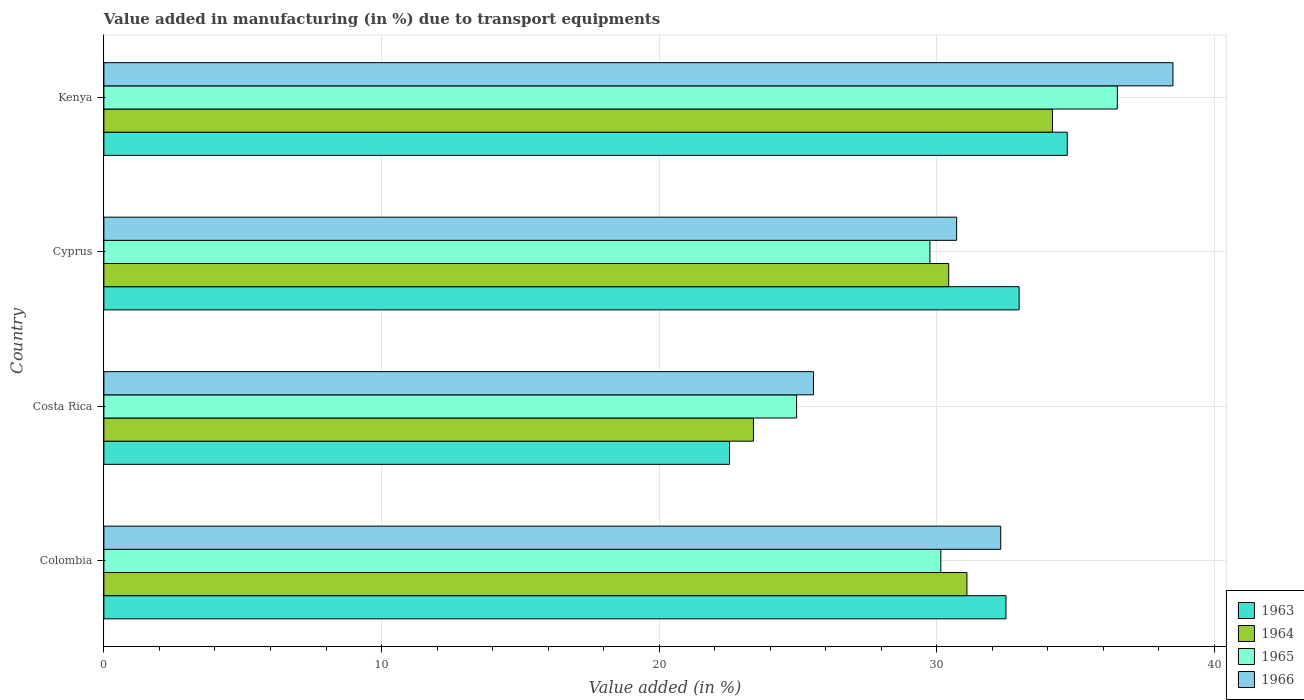Are the number of bars per tick equal to the number of legend labels?
Provide a succinct answer. Yes. How many bars are there on the 1st tick from the top?
Keep it short and to the point. 4. What is the label of the 4th group of bars from the top?
Ensure brevity in your answer.  Colombia. In how many cases, is the number of bars for a given country not equal to the number of legend labels?
Provide a short and direct response. 0. What is the percentage of value added in manufacturing due to transport equipments in 1964 in Costa Rica?
Give a very brief answer. 23.4. Across all countries, what is the maximum percentage of value added in manufacturing due to transport equipments in 1963?
Provide a short and direct response. 34.7. Across all countries, what is the minimum percentage of value added in manufacturing due to transport equipments in 1966?
Provide a succinct answer. 25.56. In which country was the percentage of value added in manufacturing due to transport equipments in 1964 maximum?
Keep it short and to the point. Kenya. In which country was the percentage of value added in manufacturing due to transport equipments in 1966 minimum?
Your answer should be compact. Costa Rica. What is the total percentage of value added in manufacturing due to transport equipments in 1965 in the graph?
Your answer should be compact. 121.35. What is the difference between the percentage of value added in manufacturing due to transport equipments in 1966 in Cyprus and that in Kenya?
Provide a succinct answer. -7.79. What is the difference between the percentage of value added in manufacturing due to transport equipments in 1963 in Colombia and the percentage of value added in manufacturing due to transport equipments in 1966 in Costa Rica?
Provide a succinct answer. 6.93. What is the average percentage of value added in manufacturing due to transport equipments in 1966 per country?
Your answer should be compact. 31.77. What is the difference between the percentage of value added in manufacturing due to transport equipments in 1963 and percentage of value added in manufacturing due to transport equipments in 1965 in Cyprus?
Make the answer very short. 3.21. In how many countries, is the percentage of value added in manufacturing due to transport equipments in 1966 greater than 10 %?
Your answer should be compact. 4. What is the ratio of the percentage of value added in manufacturing due to transport equipments in 1966 in Costa Rica to that in Kenya?
Your response must be concise. 0.66. What is the difference between the highest and the second highest percentage of value added in manufacturing due to transport equipments in 1966?
Your response must be concise. 6.2. What is the difference between the highest and the lowest percentage of value added in manufacturing due to transport equipments in 1965?
Ensure brevity in your answer.  11.55. What does the 2nd bar from the top in Colombia represents?
Keep it short and to the point. 1965. What does the 2nd bar from the bottom in Cyprus represents?
Provide a succinct answer. 1964. Is it the case that in every country, the sum of the percentage of value added in manufacturing due to transport equipments in 1966 and percentage of value added in manufacturing due to transport equipments in 1964 is greater than the percentage of value added in manufacturing due to transport equipments in 1965?
Ensure brevity in your answer.  Yes. Are all the bars in the graph horizontal?
Your answer should be compact. Yes. What is the difference between two consecutive major ticks on the X-axis?
Ensure brevity in your answer.  10. Are the values on the major ticks of X-axis written in scientific E-notation?
Offer a terse response. No. Does the graph contain any zero values?
Make the answer very short. No. Where does the legend appear in the graph?
Offer a terse response. Bottom right. How many legend labels are there?
Provide a short and direct response. 4. What is the title of the graph?
Make the answer very short. Value added in manufacturing (in %) due to transport equipments. What is the label or title of the X-axis?
Make the answer very short. Value added (in %). What is the Value added (in %) in 1963 in Colombia?
Ensure brevity in your answer.  32.49. What is the Value added (in %) of 1964 in Colombia?
Make the answer very short. 31.09. What is the Value added (in %) of 1965 in Colombia?
Keep it short and to the point. 30.15. What is the Value added (in %) in 1966 in Colombia?
Your answer should be compact. 32.3. What is the Value added (in %) in 1963 in Costa Rica?
Your response must be concise. 22.53. What is the Value added (in %) of 1964 in Costa Rica?
Ensure brevity in your answer.  23.4. What is the Value added (in %) of 1965 in Costa Rica?
Ensure brevity in your answer.  24.95. What is the Value added (in %) of 1966 in Costa Rica?
Ensure brevity in your answer.  25.56. What is the Value added (in %) in 1963 in Cyprus?
Provide a succinct answer. 32.97. What is the Value added (in %) in 1964 in Cyprus?
Provide a short and direct response. 30.43. What is the Value added (in %) of 1965 in Cyprus?
Your answer should be very brief. 29.75. What is the Value added (in %) in 1966 in Cyprus?
Your answer should be very brief. 30.72. What is the Value added (in %) of 1963 in Kenya?
Provide a short and direct response. 34.7. What is the Value added (in %) in 1964 in Kenya?
Offer a terse response. 34.17. What is the Value added (in %) in 1965 in Kenya?
Offer a terse response. 36.5. What is the Value added (in %) of 1966 in Kenya?
Your response must be concise. 38.51. Across all countries, what is the maximum Value added (in %) of 1963?
Ensure brevity in your answer.  34.7. Across all countries, what is the maximum Value added (in %) of 1964?
Your answer should be compact. 34.17. Across all countries, what is the maximum Value added (in %) in 1965?
Provide a succinct answer. 36.5. Across all countries, what is the maximum Value added (in %) of 1966?
Keep it short and to the point. 38.51. Across all countries, what is the minimum Value added (in %) of 1963?
Keep it short and to the point. 22.53. Across all countries, what is the minimum Value added (in %) of 1964?
Ensure brevity in your answer.  23.4. Across all countries, what is the minimum Value added (in %) of 1965?
Provide a succinct answer. 24.95. Across all countries, what is the minimum Value added (in %) of 1966?
Provide a short and direct response. 25.56. What is the total Value added (in %) in 1963 in the graph?
Your answer should be very brief. 122.69. What is the total Value added (in %) in 1964 in the graph?
Your answer should be very brief. 119.08. What is the total Value added (in %) of 1965 in the graph?
Your answer should be very brief. 121.35. What is the total Value added (in %) in 1966 in the graph?
Ensure brevity in your answer.  127.09. What is the difference between the Value added (in %) in 1963 in Colombia and that in Costa Rica?
Offer a terse response. 9.96. What is the difference between the Value added (in %) in 1964 in Colombia and that in Costa Rica?
Provide a short and direct response. 7.69. What is the difference between the Value added (in %) in 1965 in Colombia and that in Costa Rica?
Provide a short and direct response. 5.2. What is the difference between the Value added (in %) in 1966 in Colombia and that in Costa Rica?
Your answer should be very brief. 6.74. What is the difference between the Value added (in %) in 1963 in Colombia and that in Cyprus?
Your answer should be compact. -0.47. What is the difference between the Value added (in %) of 1964 in Colombia and that in Cyprus?
Keep it short and to the point. 0.66. What is the difference between the Value added (in %) in 1965 in Colombia and that in Cyprus?
Your response must be concise. 0.39. What is the difference between the Value added (in %) in 1966 in Colombia and that in Cyprus?
Provide a succinct answer. 1.59. What is the difference between the Value added (in %) of 1963 in Colombia and that in Kenya?
Your answer should be very brief. -2.21. What is the difference between the Value added (in %) of 1964 in Colombia and that in Kenya?
Offer a terse response. -3.08. What is the difference between the Value added (in %) in 1965 in Colombia and that in Kenya?
Your answer should be very brief. -6.36. What is the difference between the Value added (in %) of 1966 in Colombia and that in Kenya?
Keep it short and to the point. -6.2. What is the difference between the Value added (in %) in 1963 in Costa Rica and that in Cyprus?
Offer a very short reply. -10.43. What is the difference between the Value added (in %) of 1964 in Costa Rica and that in Cyprus?
Make the answer very short. -7.03. What is the difference between the Value added (in %) in 1965 in Costa Rica and that in Cyprus?
Provide a short and direct response. -4.8. What is the difference between the Value added (in %) in 1966 in Costa Rica and that in Cyprus?
Offer a very short reply. -5.16. What is the difference between the Value added (in %) of 1963 in Costa Rica and that in Kenya?
Your response must be concise. -12.17. What is the difference between the Value added (in %) in 1964 in Costa Rica and that in Kenya?
Ensure brevity in your answer.  -10.77. What is the difference between the Value added (in %) of 1965 in Costa Rica and that in Kenya?
Keep it short and to the point. -11.55. What is the difference between the Value added (in %) of 1966 in Costa Rica and that in Kenya?
Your answer should be very brief. -12.95. What is the difference between the Value added (in %) of 1963 in Cyprus and that in Kenya?
Offer a terse response. -1.73. What is the difference between the Value added (in %) of 1964 in Cyprus and that in Kenya?
Provide a short and direct response. -3.74. What is the difference between the Value added (in %) of 1965 in Cyprus and that in Kenya?
Provide a short and direct response. -6.75. What is the difference between the Value added (in %) in 1966 in Cyprus and that in Kenya?
Your answer should be compact. -7.79. What is the difference between the Value added (in %) in 1963 in Colombia and the Value added (in %) in 1964 in Costa Rica?
Provide a succinct answer. 9.1. What is the difference between the Value added (in %) in 1963 in Colombia and the Value added (in %) in 1965 in Costa Rica?
Keep it short and to the point. 7.54. What is the difference between the Value added (in %) in 1963 in Colombia and the Value added (in %) in 1966 in Costa Rica?
Make the answer very short. 6.93. What is the difference between the Value added (in %) of 1964 in Colombia and the Value added (in %) of 1965 in Costa Rica?
Your response must be concise. 6.14. What is the difference between the Value added (in %) of 1964 in Colombia and the Value added (in %) of 1966 in Costa Rica?
Make the answer very short. 5.53. What is the difference between the Value added (in %) of 1965 in Colombia and the Value added (in %) of 1966 in Costa Rica?
Keep it short and to the point. 4.59. What is the difference between the Value added (in %) of 1963 in Colombia and the Value added (in %) of 1964 in Cyprus?
Offer a terse response. 2.06. What is the difference between the Value added (in %) in 1963 in Colombia and the Value added (in %) in 1965 in Cyprus?
Offer a terse response. 2.74. What is the difference between the Value added (in %) of 1963 in Colombia and the Value added (in %) of 1966 in Cyprus?
Provide a succinct answer. 1.78. What is the difference between the Value added (in %) of 1964 in Colombia and the Value added (in %) of 1965 in Cyprus?
Provide a short and direct response. 1.33. What is the difference between the Value added (in %) in 1964 in Colombia and the Value added (in %) in 1966 in Cyprus?
Ensure brevity in your answer.  0.37. What is the difference between the Value added (in %) of 1965 in Colombia and the Value added (in %) of 1966 in Cyprus?
Keep it short and to the point. -0.57. What is the difference between the Value added (in %) in 1963 in Colombia and the Value added (in %) in 1964 in Kenya?
Ensure brevity in your answer.  -1.68. What is the difference between the Value added (in %) of 1963 in Colombia and the Value added (in %) of 1965 in Kenya?
Keep it short and to the point. -4.01. What is the difference between the Value added (in %) of 1963 in Colombia and the Value added (in %) of 1966 in Kenya?
Your answer should be very brief. -6.01. What is the difference between the Value added (in %) in 1964 in Colombia and the Value added (in %) in 1965 in Kenya?
Give a very brief answer. -5.42. What is the difference between the Value added (in %) in 1964 in Colombia and the Value added (in %) in 1966 in Kenya?
Make the answer very short. -7.42. What is the difference between the Value added (in %) in 1965 in Colombia and the Value added (in %) in 1966 in Kenya?
Offer a very short reply. -8.36. What is the difference between the Value added (in %) in 1963 in Costa Rica and the Value added (in %) in 1964 in Cyprus?
Offer a terse response. -7.9. What is the difference between the Value added (in %) in 1963 in Costa Rica and the Value added (in %) in 1965 in Cyprus?
Provide a succinct answer. -7.22. What is the difference between the Value added (in %) in 1963 in Costa Rica and the Value added (in %) in 1966 in Cyprus?
Make the answer very short. -8.18. What is the difference between the Value added (in %) in 1964 in Costa Rica and the Value added (in %) in 1965 in Cyprus?
Your response must be concise. -6.36. What is the difference between the Value added (in %) of 1964 in Costa Rica and the Value added (in %) of 1966 in Cyprus?
Provide a short and direct response. -7.32. What is the difference between the Value added (in %) in 1965 in Costa Rica and the Value added (in %) in 1966 in Cyprus?
Your response must be concise. -5.77. What is the difference between the Value added (in %) of 1963 in Costa Rica and the Value added (in %) of 1964 in Kenya?
Your response must be concise. -11.64. What is the difference between the Value added (in %) in 1963 in Costa Rica and the Value added (in %) in 1965 in Kenya?
Provide a succinct answer. -13.97. What is the difference between the Value added (in %) of 1963 in Costa Rica and the Value added (in %) of 1966 in Kenya?
Your response must be concise. -15.97. What is the difference between the Value added (in %) in 1964 in Costa Rica and the Value added (in %) in 1965 in Kenya?
Provide a short and direct response. -13.11. What is the difference between the Value added (in %) of 1964 in Costa Rica and the Value added (in %) of 1966 in Kenya?
Your answer should be very brief. -15.11. What is the difference between the Value added (in %) in 1965 in Costa Rica and the Value added (in %) in 1966 in Kenya?
Offer a terse response. -13.56. What is the difference between the Value added (in %) in 1963 in Cyprus and the Value added (in %) in 1964 in Kenya?
Keep it short and to the point. -1.2. What is the difference between the Value added (in %) in 1963 in Cyprus and the Value added (in %) in 1965 in Kenya?
Provide a succinct answer. -3.54. What is the difference between the Value added (in %) in 1963 in Cyprus and the Value added (in %) in 1966 in Kenya?
Make the answer very short. -5.54. What is the difference between the Value added (in %) in 1964 in Cyprus and the Value added (in %) in 1965 in Kenya?
Provide a short and direct response. -6.07. What is the difference between the Value added (in %) of 1964 in Cyprus and the Value added (in %) of 1966 in Kenya?
Provide a short and direct response. -8.08. What is the difference between the Value added (in %) of 1965 in Cyprus and the Value added (in %) of 1966 in Kenya?
Keep it short and to the point. -8.75. What is the average Value added (in %) of 1963 per country?
Make the answer very short. 30.67. What is the average Value added (in %) of 1964 per country?
Your response must be concise. 29.77. What is the average Value added (in %) of 1965 per country?
Keep it short and to the point. 30.34. What is the average Value added (in %) of 1966 per country?
Provide a short and direct response. 31.77. What is the difference between the Value added (in %) in 1963 and Value added (in %) in 1964 in Colombia?
Offer a very short reply. 1.41. What is the difference between the Value added (in %) in 1963 and Value added (in %) in 1965 in Colombia?
Give a very brief answer. 2.35. What is the difference between the Value added (in %) in 1963 and Value added (in %) in 1966 in Colombia?
Ensure brevity in your answer.  0.19. What is the difference between the Value added (in %) of 1964 and Value added (in %) of 1965 in Colombia?
Offer a very short reply. 0.94. What is the difference between the Value added (in %) in 1964 and Value added (in %) in 1966 in Colombia?
Provide a short and direct response. -1.22. What is the difference between the Value added (in %) of 1965 and Value added (in %) of 1966 in Colombia?
Keep it short and to the point. -2.16. What is the difference between the Value added (in %) in 1963 and Value added (in %) in 1964 in Costa Rica?
Your response must be concise. -0.86. What is the difference between the Value added (in %) in 1963 and Value added (in %) in 1965 in Costa Rica?
Provide a short and direct response. -2.42. What is the difference between the Value added (in %) of 1963 and Value added (in %) of 1966 in Costa Rica?
Provide a succinct answer. -3.03. What is the difference between the Value added (in %) of 1964 and Value added (in %) of 1965 in Costa Rica?
Give a very brief answer. -1.55. What is the difference between the Value added (in %) in 1964 and Value added (in %) in 1966 in Costa Rica?
Keep it short and to the point. -2.16. What is the difference between the Value added (in %) of 1965 and Value added (in %) of 1966 in Costa Rica?
Your answer should be very brief. -0.61. What is the difference between the Value added (in %) in 1963 and Value added (in %) in 1964 in Cyprus?
Ensure brevity in your answer.  2.54. What is the difference between the Value added (in %) of 1963 and Value added (in %) of 1965 in Cyprus?
Offer a terse response. 3.21. What is the difference between the Value added (in %) of 1963 and Value added (in %) of 1966 in Cyprus?
Your response must be concise. 2.25. What is the difference between the Value added (in %) in 1964 and Value added (in %) in 1965 in Cyprus?
Offer a very short reply. 0.68. What is the difference between the Value added (in %) of 1964 and Value added (in %) of 1966 in Cyprus?
Ensure brevity in your answer.  -0.29. What is the difference between the Value added (in %) in 1965 and Value added (in %) in 1966 in Cyprus?
Ensure brevity in your answer.  -0.96. What is the difference between the Value added (in %) of 1963 and Value added (in %) of 1964 in Kenya?
Ensure brevity in your answer.  0.53. What is the difference between the Value added (in %) in 1963 and Value added (in %) in 1965 in Kenya?
Offer a terse response. -1.8. What is the difference between the Value added (in %) of 1963 and Value added (in %) of 1966 in Kenya?
Make the answer very short. -3.81. What is the difference between the Value added (in %) in 1964 and Value added (in %) in 1965 in Kenya?
Offer a terse response. -2.33. What is the difference between the Value added (in %) in 1964 and Value added (in %) in 1966 in Kenya?
Your answer should be very brief. -4.34. What is the difference between the Value added (in %) of 1965 and Value added (in %) of 1966 in Kenya?
Give a very brief answer. -2. What is the ratio of the Value added (in %) in 1963 in Colombia to that in Costa Rica?
Keep it short and to the point. 1.44. What is the ratio of the Value added (in %) in 1964 in Colombia to that in Costa Rica?
Your response must be concise. 1.33. What is the ratio of the Value added (in %) of 1965 in Colombia to that in Costa Rica?
Give a very brief answer. 1.21. What is the ratio of the Value added (in %) of 1966 in Colombia to that in Costa Rica?
Make the answer very short. 1.26. What is the ratio of the Value added (in %) in 1963 in Colombia to that in Cyprus?
Provide a succinct answer. 0.99. What is the ratio of the Value added (in %) in 1964 in Colombia to that in Cyprus?
Offer a terse response. 1.02. What is the ratio of the Value added (in %) of 1965 in Colombia to that in Cyprus?
Keep it short and to the point. 1.01. What is the ratio of the Value added (in %) of 1966 in Colombia to that in Cyprus?
Provide a succinct answer. 1.05. What is the ratio of the Value added (in %) in 1963 in Colombia to that in Kenya?
Ensure brevity in your answer.  0.94. What is the ratio of the Value added (in %) in 1964 in Colombia to that in Kenya?
Offer a terse response. 0.91. What is the ratio of the Value added (in %) of 1965 in Colombia to that in Kenya?
Give a very brief answer. 0.83. What is the ratio of the Value added (in %) of 1966 in Colombia to that in Kenya?
Provide a succinct answer. 0.84. What is the ratio of the Value added (in %) of 1963 in Costa Rica to that in Cyprus?
Your response must be concise. 0.68. What is the ratio of the Value added (in %) in 1964 in Costa Rica to that in Cyprus?
Offer a terse response. 0.77. What is the ratio of the Value added (in %) of 1965 in Costa Rica to that in Cyprus?
Your answer should be compact. 0.84. What is the ratio of the Value added (in %) of 1966 in Costa Rica to that in Cyprus?
Provide a succinct answer. 0.83. What is the ratio of the Value added (in %) of 1963 in Costa Rica to that in Kenya?
Give a very brief answer. 0.65. What is the ratio of the Value added (in %) in 1964 in Costa Rica to that in Kenya?
Your response must be concise. 0.68. What is the ratio of the Value added (in %) of 1965 in Costa Rica to that in Kenya?
Offer a very short reply. 0.68. What is the ratio of the Value added (in %) in 1966 in Costa Rica to that in Kenya?
Your answer should be very brief. 0.66. What is the ratio of the Value added (in %) of 1963 in Cyprus to that in Kenya?
Provide a succinct answer. 0.95. What is the ratio of the Value added (in %) of 1964 in Cyprus to that in Kenya?
Your response must be concise. 0.89. What is the ratio of the Value added (in %) of 1965 in Cyprus to that in Kenya?
Provide a succinct answer. 0.82. What is the ratio of the Value added (in %) of 1966 in Cyprus to that in Kenya?
Your answer should be very brief. 0.8. What is the difference between the highest and the second highest Value added (in %) of 1963?
Offer a terse response. 1.73. What is the difference between the highest and the second highest Value added (in %) of 1964?
Offer a very short reply. 3.08. What is the difference between the highest and the second highest Value added (in %) of 1965?
Your answer should be very brief. 6.36. What is the difference between the highest and the second highest Value added (in %) in 1966?
Your response must be concise. 6.2. What is the difference between the highest and the lowest Value added (in %) of 1963?
Offer a very short reply. 12.17. What is the difference between the highest and the lowest Value added (in %) in 1964?
Provide a short and direct response. 10.77. What is the difference between the highest and the lowest Value added (in %) of 1965?
Provide a succinct answer. 11.55. What is the difference between the highest and the lowest Value added (in %) in 1966?
Provide a short and direct response. 12.95. 